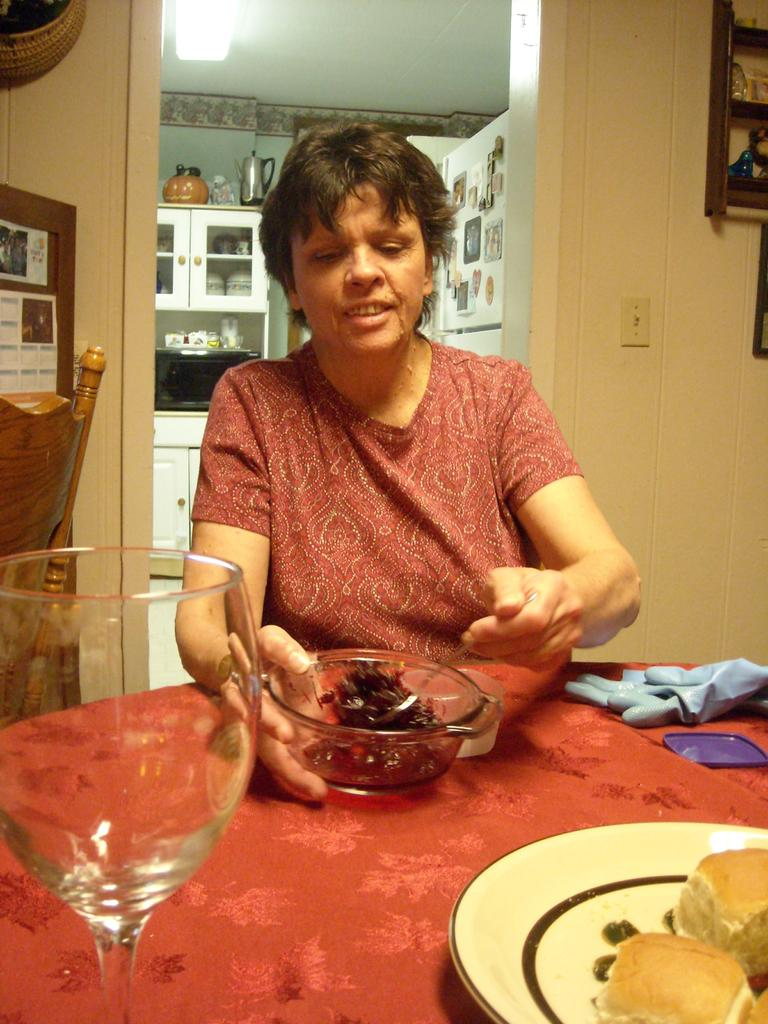Who is present in the image? There is a woman in the image. What is the woman doing in the image? The woman is sitting. What can be seen on the table in the image? There is a bowl with food items and a wine glass on the table in the image. What type of knot is the woman using to tie her shirt in the image? There is no knot or shirt present in the image; the woman is simply sitting. What color is the sheet on the table in the image? There is no sheet present in the image; only a bowl with food items, a wine glass, and a table are visible. 